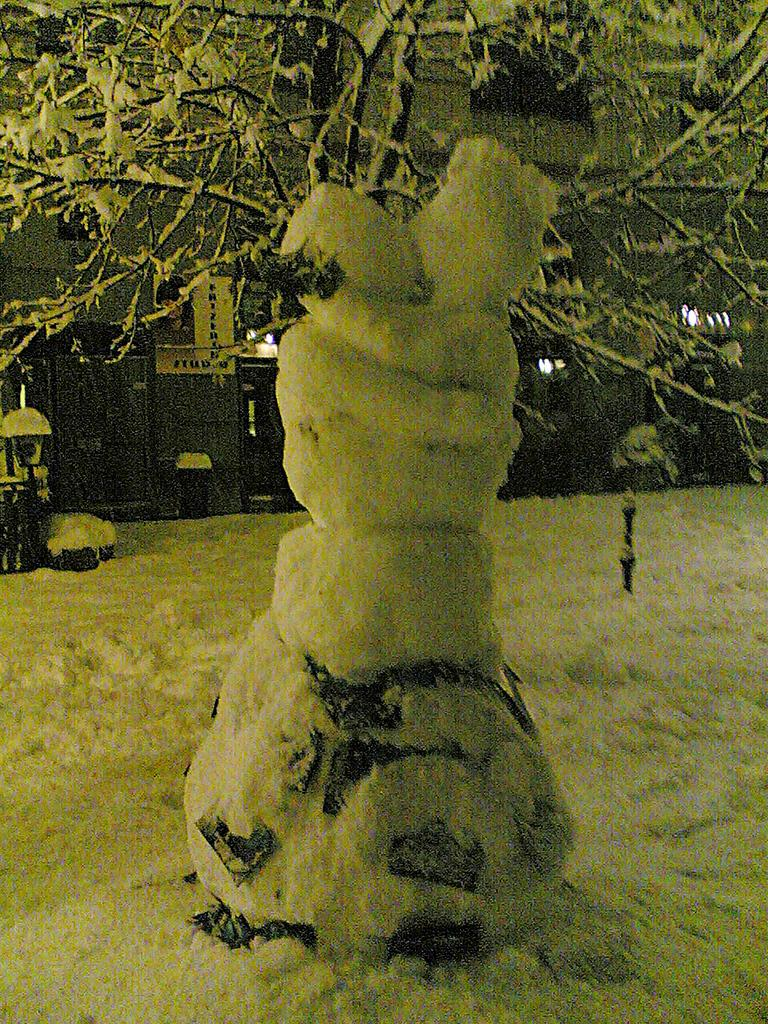What is the main object in the image? There is a tree in the image. What is the condition of the tree? The tree is covered by snow. What can be seen in the background of the image? There is a building and a board visible in the background of the image. What type of nut is being used to fix the linen on the board in the image? There is no nut or linen present in the image; it only features a tree covered in snow and a building in the background. 